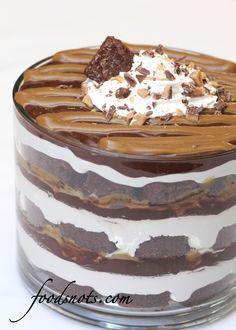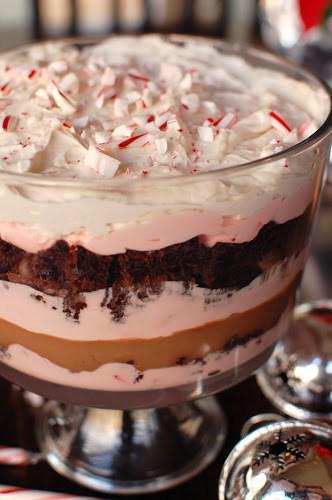The first image is the image on the left, the second image is the image on the right. For the images shown, is this caption "There is a layered dessert in a clear container that shows three layers of chocolate cake and at least three layers of cream filling." true? Answer yes or no. Yes. The first image is the image on the left, the second image is the image on the right. Considering the images on both sides, is "Both of the trifles are in glass dishes with stands." valid? Answer yes or no. No. 